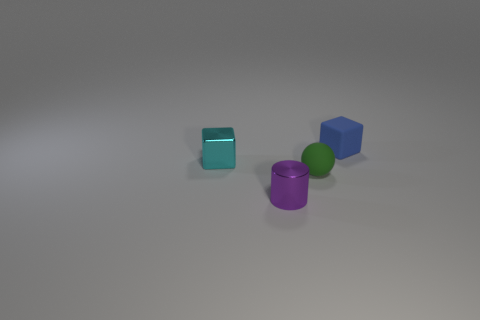There is a rubber thing that is behind the tiny ball; what is its color?
Offer a terse response. Blue. There is a matte cube that is the same size as the purple cylinder; what color is it?
Provide a succinct answer. Blue. Do the small purple shiny thing and the cyan thing have the same shape?
Your answer should be compact. No. There is a tiny cube that is right of the small green rubber sphere; what is its material?
Provide a succinct answer. Rubber. The ball has what color?
Offer a very short reply. Green. The matte object that is the same shape as the small cyan metallic thing is what color?
Your response must be concise. Blue. Are there more shiny objects on the left side of the shiny cylinder than small balls on the right side of the small green matte thing?
Offer a terse response. Yes. How many other objects are the same shape as the small blue thing?
Keep it short and to the point. 1. Are there any small metal objects that are in front of the matte object to the left of the small blue matte block?
Provide a short and direct response. Yes. How many large yellow matte cubes are there?
Your answer should be very brief. 0. 